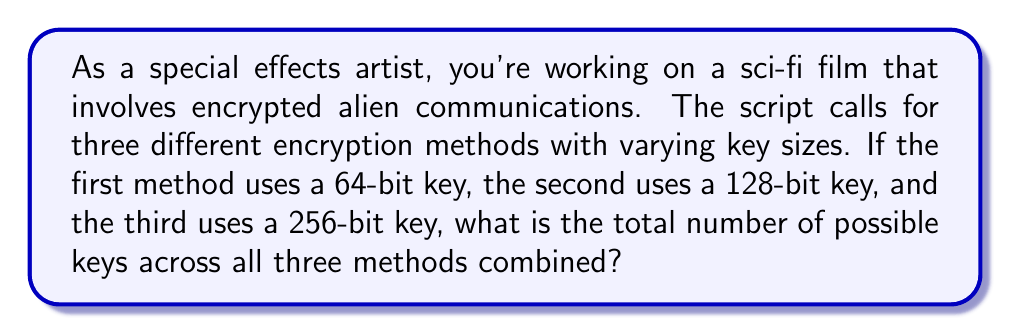What is the answer to this math problem? To solve this problem, we need to calculate the key space for each encryption method and then sum them up. The key space is determined by the number of possible combinations for a given key size.

1. For a 64-bit key:
   The number of possible keys is $2^{64}$.

2. For a 128-bit key:
   The number of possible keys is $2^{128}$.

3. For a 256-bit key:
   The number of possible keys is $2^{256}$.

To find the total number of possible keys, we add these together:

$$\text{Total key space} = 2^{64} + 2^{128} + 2^{256}$$

We can simplify this by expressing it in terms of the largest exponent:

$$\text{Total key space} = 2^{256} + 2^{128} + 2^{64}$$
$$= 2^{256} + 2^{256-128} + 2^{256-192}$$
$$= 2^{256} + 2^{128} + 2^{64}$$
$$= 2^{256} (1 + 2^{-128} + 2^{-192})$$

This expression represents the exact total key space size.
Answer: $2^{256} (1 + 2^{-128} + 2^{-192})$ 